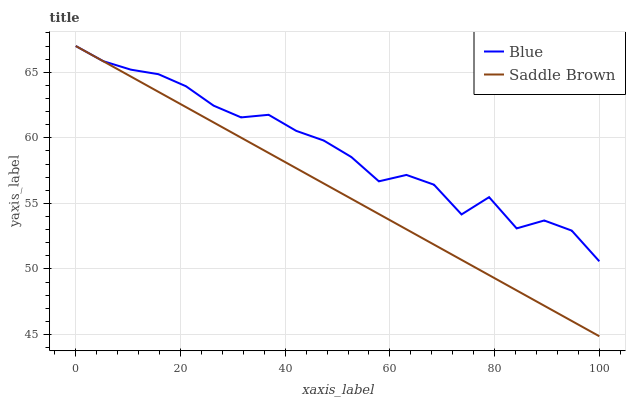Does Saddle Brown have the maximum area under the curve?
Answer yes or no. No. Is Saddle Brown the roughest?
Answer yes or no. No. 